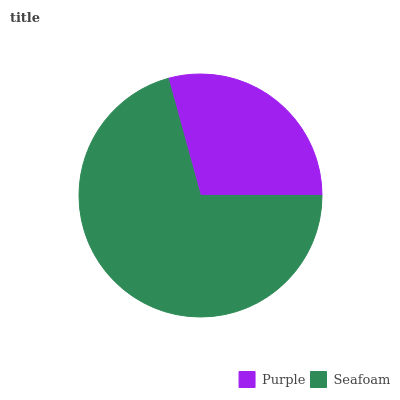Is Purple the minimum?
Answer yes or no. Yes. Is Seafoam the maximum?
Answer yes or no. Yes. Is Seafoam the minimum?
Answer yes or no. No. Is Seafoam greater than Purple?
Answer yes or no. Yes. Is Purple less than Seafoam?
Answer yes or no. Yes. Is Purple greater than Seafoam?
Answer yes or no. No. Is Seafoam less than Purple?
Answer yes or no. No. Is Seafoam the high median?
Answer yes or no. Yes. Is Purple the low median?
Answer yes or no. Yes. Is Purple the high median?
Answer yes or no. No. Is Seafoam the low median?
Answer yes or no. No. 